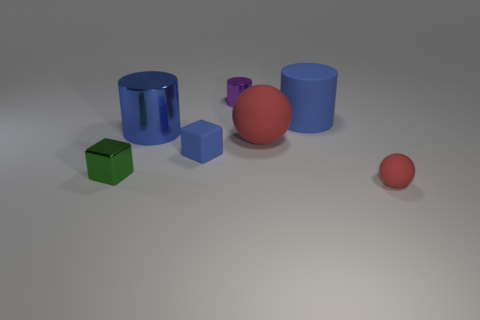Are there any shadows that suggest a light source direction in the image? Yes, there are shadows extending to the right of the objects. The angle and length of these shadows indicate that the light source is coming from the left side of the frame, casting shadows diagonally towards the right. 